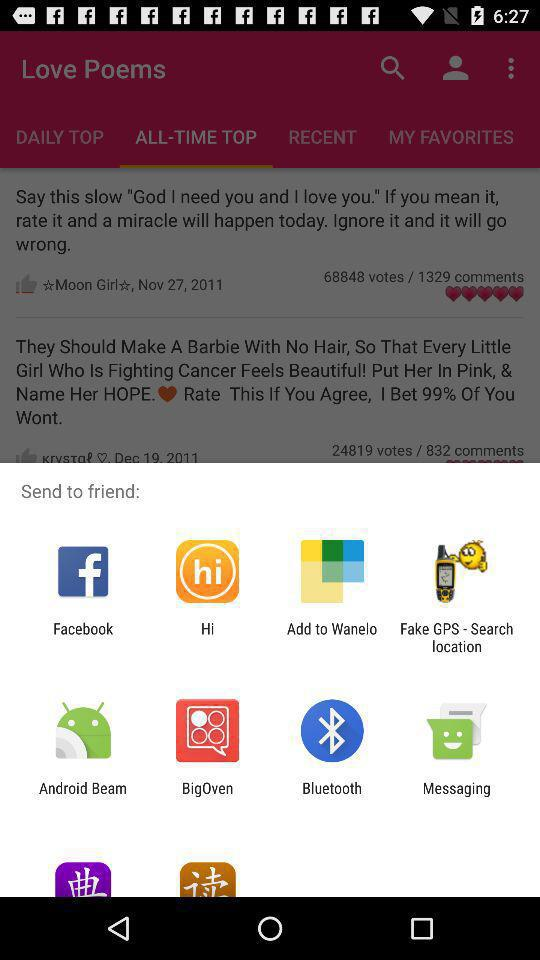Which options are given for sharing? The given options are "Facebook", "Hi", "Add to Wanelo", "Fake GPS - Search location", "Android Beam", "BigOven", "Bluetooth" and "Messaging". 